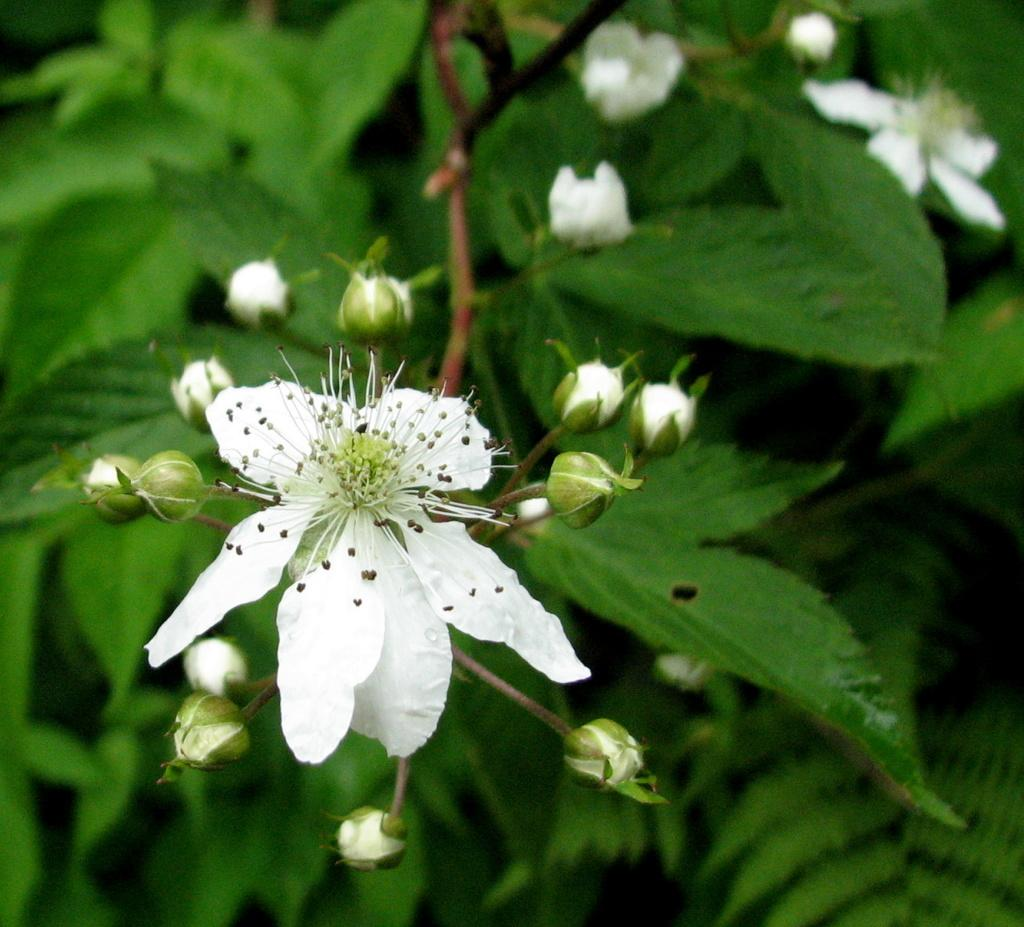What type of plants can be seen in the image? There are flowers in the image. What stage of growth are the plants on the tree in the image? There are buds on a tree in the image, indicating that they are in the early stages of growth. What position does the book occupy in the image? There are no books present in the image. What is the temper of the flowers in the image? The temper of the flowers cannot be determined from the image, as flowers do not have emotions or temperament. 